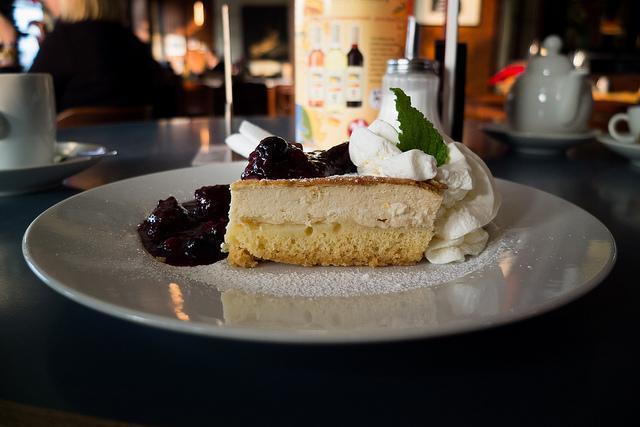How many layers is the cake?
Give a very brief answer. 2. How many train cars are behind the locomotive?
Give a very brief answer. 0. 